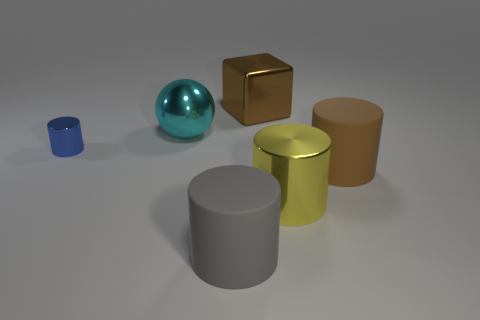Add 4 big metal cubes. How many objects exist? 10 Subtract all cyan cylinders. Subtract all purple cubes. How many cylinders are left? 4 Subtract all cylinders. How many objects are left? 2 Add 5 big rubber cylinders. How many big rubber cylinders are left? 7 Add 1 big objects. How many big objects exist? 6 Subtract 0 yellow balls. How many objects are left? 6 Subtract all spheres. Subtract all large brown rubber cylinders. How many objects are left? 4 